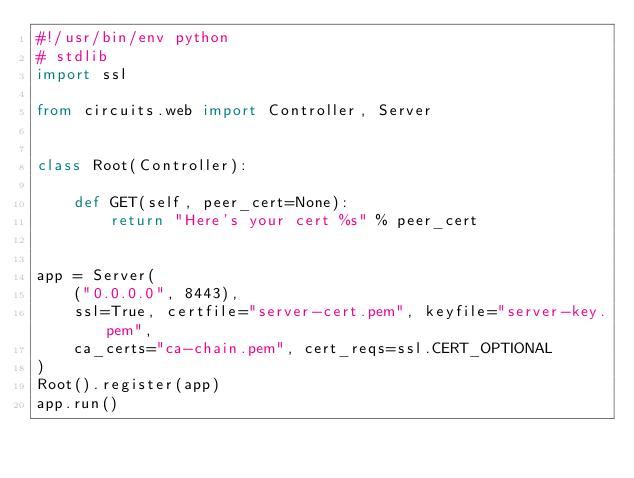Convert code to text. <code><loc_0><loc_0><loc_500><loc_500><_Python_>#!/usr/bin/env python
# stdlib
import ssl

from circuits.web import Controller, Server


class Root(Controller):

    def GET(self, peer_cert=None):
        return "Here's your cert %s" % peer_cert


app = Server(
    ("0.0.0.0", 8443),
    ssl=True, certfile="server-cert.pem", keyfile="server-key.pem",
    ca_certs="ca-chain.pem", cert_reqs=ssl.CERT_OPTIONAL
)
Root().register(app)
app.run()
</code> 